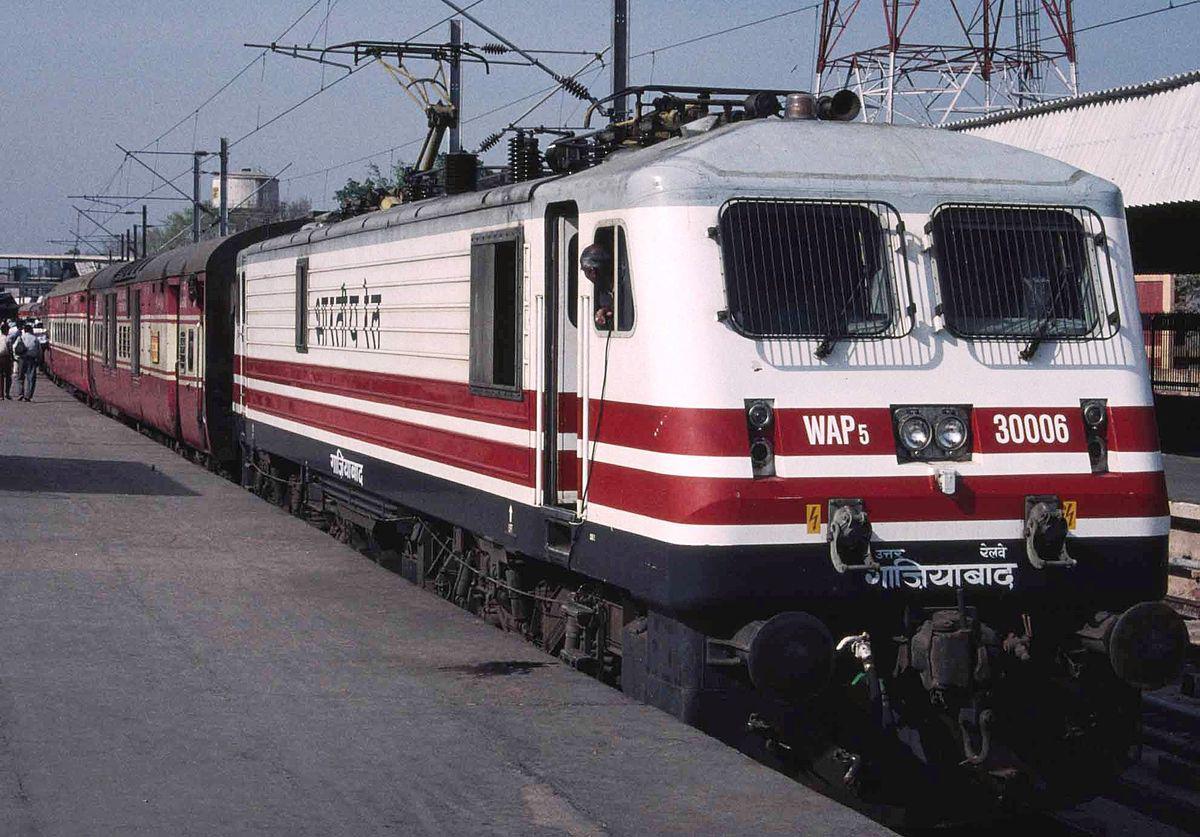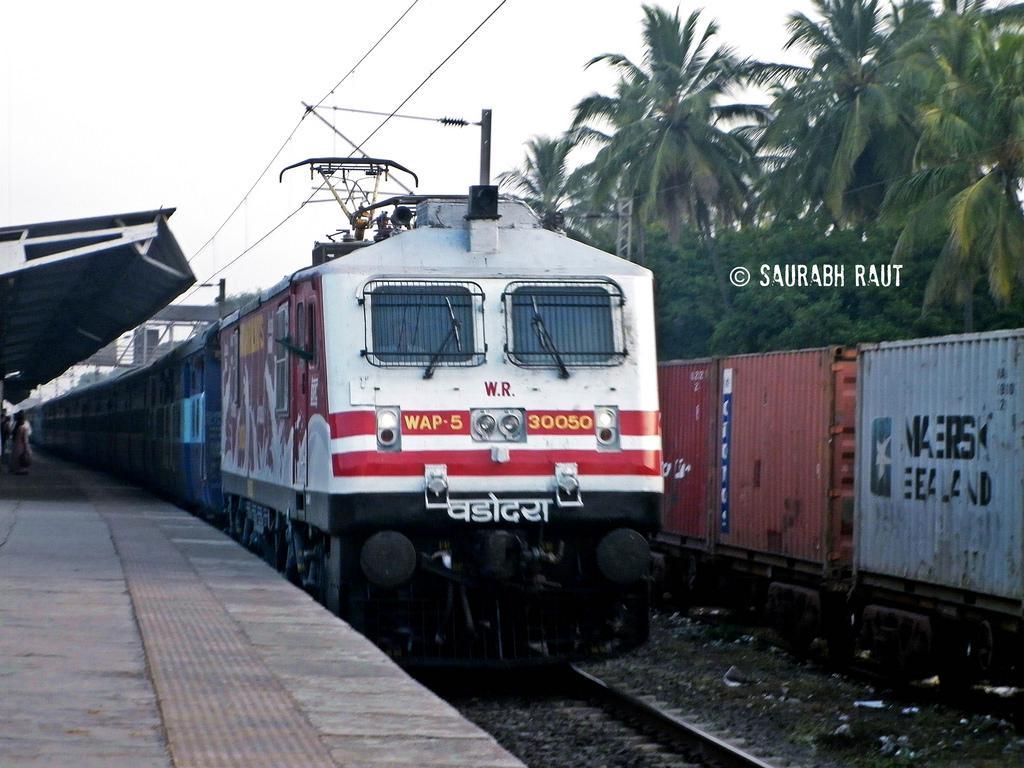The first image is the image on the left, the second image is the image on the right. Given the left and right images, does the statement "There are two trains in one of the images." hold true? Answer yes or no. Yes. 